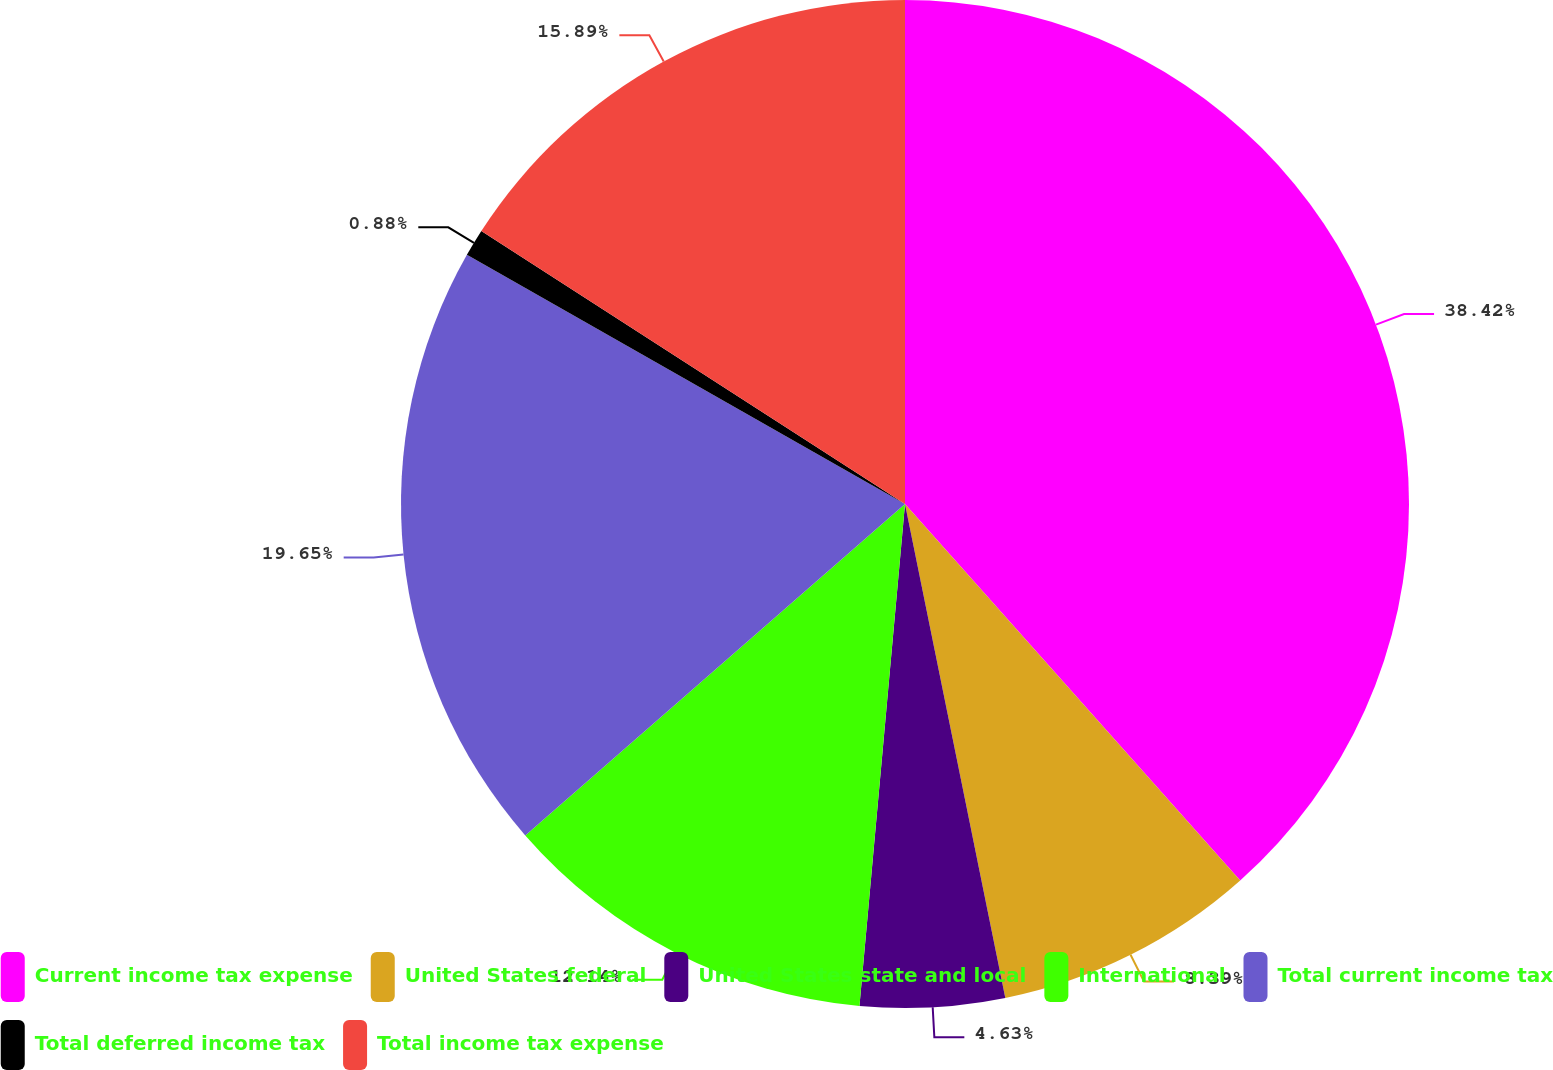<chart> <loc_0><loc_0><loc_500><loc_500><pie_chart><fcel>Current income tax expense<fcel>United States federal<fcel>United States state and local<fcel>International<fcel>Total current income tax<fcel>Total deferred income tax<fcel>Total income tax expense<nl><fcel>38.42%<fcel>8.39%<fcel>4.63%<fcel>12.14%<fcel>19.65%<fcel>0.88%<fcel>15.89%<nl></chart> 